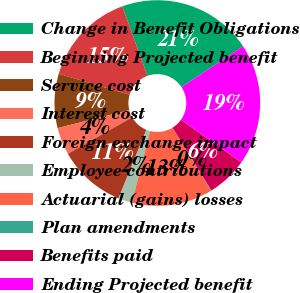Convert chart to OTSL. <chart><loc_0><loc_0><loc_500><loc_500><pie_chart><fcel>Change in Benefit Obligations<fcel>Beginning Projected benefit<fcel>Service cost<fcel>Interest cost<fcel>Foreign exchange impact<fcel>Employee contributions<fcel>Actuarial (gains) losses<fcel>Plan amendments<fcel>Benefits paid<fcel>Ending Projected benefit<nl><fcel>21.22%<fcel>14.87%<fcel>8.52%<fcel>4.29%<fcel>10.63%<fcel>2.17%<fcel>12.75%<fcel>0.05%<fcel>6.4%<fcel>19.1%<nl></chart> 